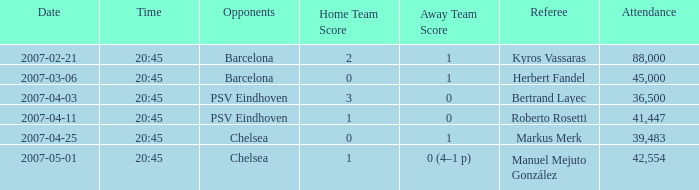What was the result of the game that began at 20:45 on march 6, 2007? 0–1. 